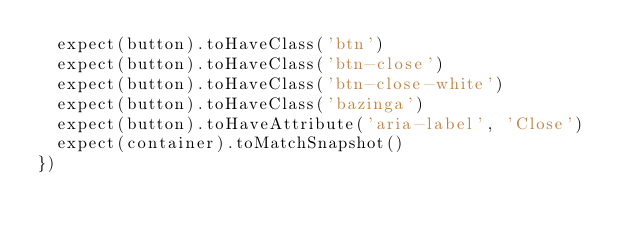<code> <loc_0><loc_0><loc_500><loc_500><_TypeScript_>  expect(button).toHaveClass('btn')
  expect(button).toHaveClass('btn-close')
  expect(button).toHaveClass('btn-close-white')
  expect(button).toHaveClass('bazinga')
  expect(button).toHaveAttribute('aria-label', 'Close')
  expect(container).toMatchSnapshot()
})
</code> 